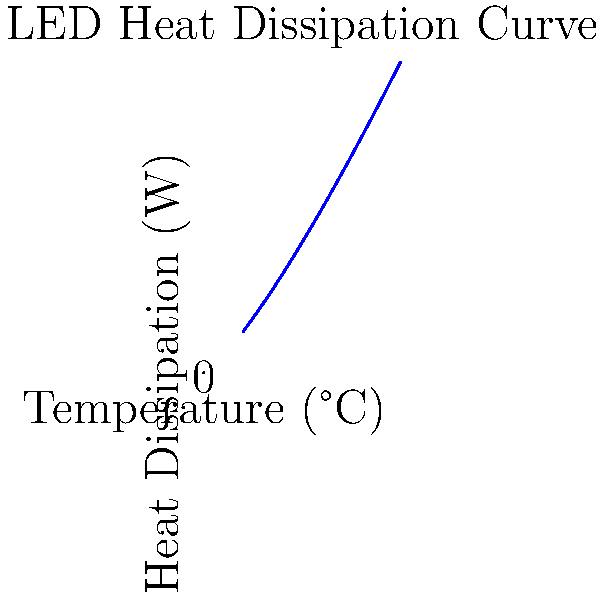As a filmmaker preparing for the Toronto International Film Festival, you're evaluating LED lighting equipment for your next production. The graph shows the relationship between temperature and heat dissipation for a specific LED light. If the ambient temperature on set is expected to be 30°C, what will be the approximate heat dissipation rate (in watts) for this LED light? To solve this problem, we need to follow these steps:

1. Understand the graph: The x-axis represents temperature in °C, and the y-axis represents heat dissipation in watts.

2. Identify the function: The curve appears to follow a power law relationship, approximately $y = 0.5x^{1.25}$, where $y$ is heat dissipation and $x$ is temperature.

3. Use the given ambient temperature: We're told the ambient temperature is 30°C, so we need to find the y-value (heat dissipation) when x = 30.

4. Calculate the heat dissipation:
   $y = 0.5 * (30)^{1.25}$
   $y = 0.5 * 69.43$
   $y \approx 34.72$ watts

5. Round to a reasonable precision: Given the approximate nature of the graph and the question, rounding to 35 watts is appropriate.

This heat dissipation rate is crucial for understanding how much cooling might be needed on set to maintain optimal LED performance and longevity during your film production.
Answer: 35 watts 